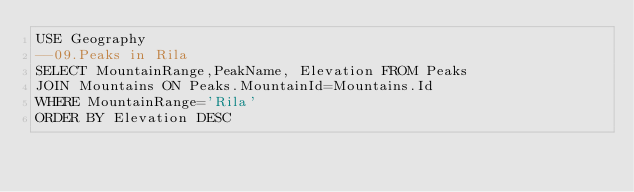Convert code to text. <code><loc_0><loc_0><loc_500><loc_500><_SQL_>USE Geography
--09.Peaks in Rila
SELECT MountainRange,PeakName, Elevation FROM Peaks
JOIN Mountains ON Peaks.MountainId=Mountains.Id
WHERE MountainRange='Rila'
ORDER BY Elevation DESC
</code> 